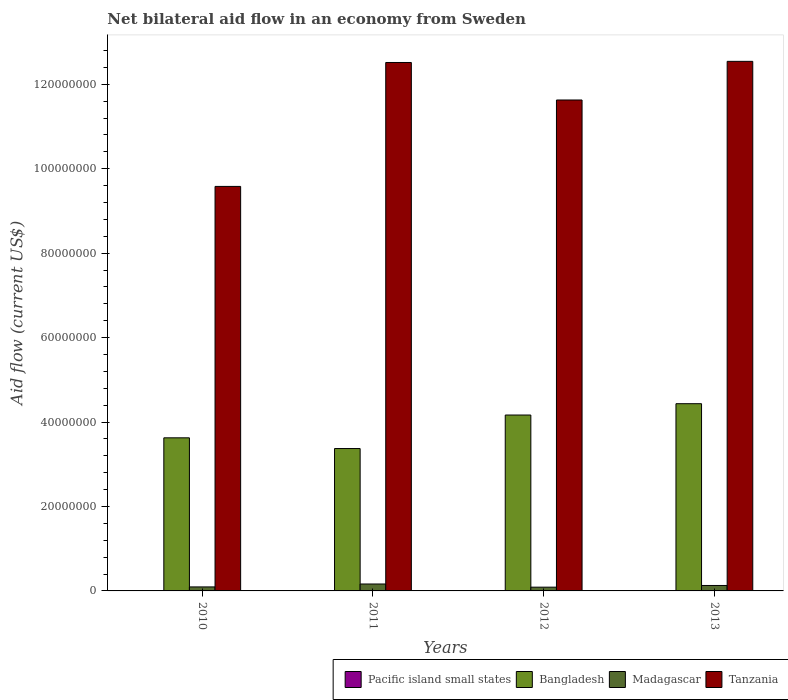How many different coloured bars are there?
Make the answer very short. 4. How many bars are there on the 3rd tick from the left?
Offer a terse response. 3. How many bars are there on the 1st tick from the right?
Offer a very short reply. 4. In how many cases, is the number of bars for a given year not equal to the number of legend labels?
Keep it short and to the point. 1. What is the net bilateral aid flow in Bangladesh in 2011?
Offer a terse response. 3.37e+07. Across all years, what is the maximum net bilateral aid flow in Madagascar?
Offer a terse response. 1.64e+06. Across all years, what is the minimum net bilateral aid flow in Pacific island small states?
Ensure brevity in your answer.  0. What is the total net bilateral aid flow in Pacific island small states in the graph?
Make the answer very short. 1.40e+05. What is the difference between the net bilateral aid flow in Tanzania in 2010 and the net bilateral aid flow in Bangladesh in 2012?
Offer a terse response. 5.41e+07. What is the average net bilateral aid flow in Pacific island small states per year?
Provide a short and direct response. 3.50e+04. In the year 2011, what is the difference between the net bilateral aid flow in Tanzania and net bilateral aid flow in Madagascar?
Provide a short and direct response. 1.24e+08. What is the ratio of the net bilateral aid flow in Tanzania in 2010 to that in 2011?
Your response must be concise. 0.77. Is the difference between the net bilateral aid flow in Tanzania in 2010 and 2013 greater than the difference between the net bilateral aid flow in Madagascar in 2010 and 2013?
Provide a short and direct response. No. In how many years, is the net bilateral aid flow in Madagascar greater than the average net bilateral aid flow in Madagascar taken over all years?
Your answer should be very brief. 2. Is the sum of the net bilateral aid flow in Tanzania in 2012 and 2013 greater than the maximum net bilateral aid flow in Madagascar across all years?
Provide a succinct answer. Yes. How many years are there in the graph?
Make the answer very short. 4. Are the values on the major ticks of Y-axis written in scientific E-notation?
Your answer should be very brief. No. Does the graph contain grids?
Ensure brevity in your answer.  No. Where does the legend appear in the graph?
Your response must be concise. Bottom right. How are the legend labels stacked?
Give a very brief answer. Horizontal. What is the title of the graph?
Offer a very short reply. Net bilateral aid flow in an economy from Sweden. What is the label or title of the X-axis?
Your answer should be very brief. Years. What is the Aid flow (current US$) in Pacific island small states in 2010?
Your answer should be very brief. 2.00e+04. What is the Aid flow (current US$) in Bangladesh in 2010?
Ensure brevity in your answer.  3.63e+07. What is the Aid flow (current US$) in Madagascar in 2010?
Your answer should be very brief. 9.50e+05. What is the Aid flow (current US$) in Tanzania in 2010?
Provide a short and direct response. 9.58e+07. What is the Aid flow (current US$) of Bangladesh in 2011?
Your answer should be very brief. 3.37e+07. What is the Aid flow (current US$) in Madagascar in 2011?
Your answer should be compact. 1.64e+06. What is the Aid flow (current US$) of Tanzania in 2011?
Offer a terse response. 1.25e+08. What is the Aid flow (current US$) in Pacific island small states in 2012?
Make the answer very short. 0. What is the Aid flow (current US$) in Bangladesh in 2012?
Give a very brief answer. 4.17e+07. What is the Aid flow (current US$) in Madagascar in 2012?
Make the answer very short. 8.90e+05. What is the Aid flow (current US$) in Tanzania in 2012?
Make the answer very short. 1.16e+08. What is the Aid flow (current US$) of Bangladesh in 2013?
Offer a terse response. 4.43e+07. What is the Aid flow (current US$) of Madagascar in 2013?
Provide a succinct answer. 1.29e+06. What is the Aid flow (current US$) of Tanzania in 2013?
Ensure brevity in your answer.  1.25e+08. Across all years, what is the maximum Aid flow (current US$) in Bangladesh?
Ensure brevity in your answer.  4.43e+07. Across all years, what is the maximum Aid flow (current US$) in Madagascar?
Offer a very short reply. 1.64e+06. Across all years, what is the maximum Aid flow (current US$) of Tanzania?
Your answer should be compact. 1.25e+08. Across all years, what is the minimum Aid flow (current US$) of Bangladesh?
Your answer should be very brief. 3.37e+07. Across all years, what is the minimum Aid flow (current US$) of Madagascar?
Give a very brief answer. 8.90e+05. Across all years, what is the minimum Aid flow (current US$) of Tanzania?
Offer a very short reply. 9.58e+07. What is the total Aid flow (current US$) in Pacific island small states in the graph?
Offer a very short reply. 1.40e+05. What is the total Aid flow (current US$) of Bangladesh in the graph?
Give a very brief answer. 1.56e+08. What is the total Aid flow (current US$) in Madagascar in the graph?
Offer a very short reply. 4.77e+06. What is the total Aid flow (current US$) in Tanzania in the graph?
Offer a terse response. 4.63e+08. What is the difference between the Aid flow (current US$) in Bangladesh in 2010 and that in 2011?
Offer a very short reply. 2.54e+06. What is the difference between the Aid flow (current US$) in Madagascar in 2010 and that in 2011?
Your response must be concise. -6.90e+05. What is the difference between the Aid flow (current US$) of Tanzania in 2010 and that in 2011?
Provide a short and direct response. -2.94e+07. What is the difference between the Aid flow (current US$) of Bangladesh in 2010 and that in 2012?
Your response must be concise. -5.40e+06. What is the difference between the Aid flow (current US$) of Madagascar in 2010 and that in 2012?
Your response must be concise. 6.00e+04. What is the difference between the Aid flow (current US$) in Tanzania in 2010 and that in 2012?
Give a very brief answer. -2.05e+07. What is the difference between the Aid flow (current US$) in Pacific island small states in 2010 and that in 2013?
Your answer should be compact. -10000. What is the difference between the Aid flow (current US$) in Bangladesh in 2010 and that in 2013?
Make the answer very short. -8.08e+06. What is the difference between the Aid flow (current US$) in Tanzania in 2010 and that in 2013?
Keep it short and to the point. -2.96e+07. What is the difference between the Aid flow (current US$) of Bangladesh in 2011 and that in 2012?
Your answer should be compact. -7.94e+06. What is the difference between the Aid flow (current US$) in Madagascar in 2011 and that in 2012?
Keep it short and to the point. 7.50e+05. What is the difference between the Aid flow (current US$) of Tanzania in 2011 and that in 2012?
Offer a very short reply. 8.88e+06. What is the difference between the Aid flow (current US$) of Pacific island small states in 2011 and that in 2013?
Ensure brevity in your answer.  6.00e+04. What is the difference between the Aid flow (current US$) in Bangladesh in 2011 and that in 2013?
Offer a very short reply. -1.06e+07. What is the difference between the Aid flow (current US$) in Bangladesh in 2012 and that in 2013?
Ensure brevity in your answer.  -2.68e+06. What is the difference between the Aid flow (current US$) of Madagascar in 2012 and that in 2013?
Your answer should be very brief. -4.00e+05. What is the difference between the Aid flow (current US$) of Tanzania in 2012 and that in 2013?
Ensure brevity in your answer.  -9.15e+06. What is the difference between the Aid flow (current US$) in Pacific island small states in 2010 and the Aid flow (current US$) in Bangladesh in 2011?
Give a very brief answer. -3.37e+07. What is the difference between the Aid flow (current US$) in Pacific island small states in 2010 and the Aid flow (current US$) in Madagascar in 2011?
Keep it short and to the point. -1.62e+06. What is the difference between the Aid flow (current US$) of Pacific island small states in 2010 and the Aid flow (current US$) of Tanzania in 2011?
Keep it short and to the point. -1.25e+08. What is the difference between the Aid flow (current US$) in Bangladesh in 2010 and the Aid flow (current US$) in Madagascar in 2011?
Provide a short and direct response. 3.46e+07. What is the difference between the Aid flow (current US$) of Bangladesh in 2010 and the Aid flow (current US$) of Tanzania in 2011?
Your response must be concise. -8.89e+07. What is the difference between the Aid flow (current US$) of Madagascar in 2010 and the Aid flow (current US$) of Tanzania in 2011?
Provide a short and direct response. -1.24e+08. What is the difference between the Aid flow (current US$) in Pacific island small states in 2010 and the Aid flow (current US$) in Bangladesh in 2012?
Offer a very short reply. -4.16e+07. What is the difference between the Aid flow (current US$) of Pacific island small states in 2010 and the Aid flow (current US$) of Madagascar in 2012?
Your response must be concise. -8.70e+05. What is the difference between the Aid flow (current US$) of Pacific island small states in 2010 and the Aid flow (current US$) of Tanzania in 2012?
Provide a succinct answer. -1.16e+08. What is the difference between the Aid flow (current US$) of Bangladesh in 2010 and the Aid flow (current US$) of Madagascar in 2012?
Your answer should be very brief. 3.54e+07. What is the difference between the Aid flow (current US$) of Bangladesh in 2010 and the Aid flow (current US$) of Tanzania in 2012?
Offer a very short reply. -8.00e+07. What is the difference between the Aid flow (current US$) in Madagascar in 2010 and the Aid flow (current US$) in Tanzania in 2012?
Give a very brief answer. -1.15e+08. What is the difference between the Aid flow (current US$) of Pacific island small states in 2010 and the Aid flow (current US$) of Bangladesh in 2013?
Your answer should be compact. -4.43e+07. What is the difference between the Aid flow (current US$) in Pacific island small states in 2010 and the Aid flow (current US$) in Madagascar in 2013?
Provide a short and direct response. -1.27e+06. What is the difference between the Aid flow (current US$) in Pacific island small states in 2010 and the Aid flow (current US$) in Tanzania in 2013?
Provide a short and direct response. -1.25e+08. What is the difference between the Aid flow (current US$) of Bangladesh in 2010 and the Aid flow (current US$) of Madagascar in 2013?
Offer a very short reply. 3.50e+07. What is the difference between the Aid flow (current US$) in Bangladesh in 2010 and the Aid flow (current US$) in Tanzania in 2013?
Your answer should be very brief. -8.92e+07. What is the difference between the Aid flow (current US$) in Madagascar in 2010 and the Aid flow (current US$) in Tanzania in 2013?
Provide a short and direct response. -1.24e+08. What is the difference between the Aid flow (current US$) of Pacific island small states in 2011 and the Aid flow (current US$) of Bangladesh in 2012?
Your answer should be compact. -4.16e+07. What is the difference between the Aid flow (current US$) in Pacific island small states in 2011 and the Aid flow (current US$) in Madagascar in 2012?
Your response must be concise. -8.00e+05. What is the difference between the Aid flow (current US$) of Pacific island small states in 2011 and the Aid flow (current US$) of Tanzania in 2012?
Your response must be concise. -1.16e+08. What is the difference between the Aid flow (current US$) in Bangladesh in 2011 and the Aid flow (current US$) in Madagascar in 2012?
Your response must be concise. 3.28e+07. What is the difference between the Aid flow (current US$) of Bangladesh in 2011 and the Aid flow (current US$) of Tanzania in 2012?
Provide a succinct answer. -8.26e+07. What is the difference between the Aid flow (current US$) of Madagascar in 2011 and the Aid flow (current US$) of Tanzania in 2012?
Your answer should be compact. -1.15e+08. What is the difference between the Aid flow (current US$) of Pacific island small states in 2011 and the Aid flow (current US$) of Bangladesh in 2013?
Offer a terse response. -4.42e+07. What is the difference between the Aid flow (current US$) in Pacific island small states in 2011 and the Aid flow (current US$) in Madagascar in 2013?
Offer a very short reply. -1.20e+06. What is the difference between the Aid flow (current US$) in Pacific island small states in 2011 and the Aid flow (current US$) in Tanzania in 2013?
Provide a short and direct response. -1.25e+08. What is the difference between the Aid flow (current US$) in Bangladesh in 2011 and the Aid flow (current US$) in Madagascar in 2013?
Your answer should be compact. 3.24e+07. What is the difference between the Aid flow (current US$) of Bangladesh in 2011 and the Aid flow (current US$) of Tanzania in 2013?
Provide a short and direct response. -9.17e+07. What is the difference between the Aid flow (current US$) in Madagascar in 2011 and the Aid flow (current US$) in Tanzania in 2013?
Your response must be concise. -1.24e+08. What is the difference between the Aid flow (current US$) in Bangladesh in 2012 and the Aid flow (current US$) in Madagascar in 2013?
Offer a very short reply. 4.04e+07. What is the difference between the Aid flow (current US$) in Bangladesh in 2012 and the Aid flow (current US$) in Tanzania in 2013?
Provide a short and direct response. -8.38e+07. What is the difference between the Aid flow (current US$) in Madagascar in 2012 and the Aid flow (current US$) in Tanzania in 2013?
Make the answer very short. -1.25e+08. What is the average Aid flow (current US$) in Pacific island small states per year?
Give a very brief answer. 3.50e+04. What is the average Aid flow (current US$) of Bangladesh per year?
Give a very brief answer. 3.90e+07. What is the average Aid flow (current US$) in Madagascar per year?
Make the answer very short. 1.19e+06. What is the average Aid flow (current US$) in Tanzania per year?
Offer a very short reply. 1.16e+08. In the year 2010, what is the difference between the Aid flow (current US$) in Pacific island small states and Aid flow (current US$) in Bangladesh?
Keep it short and to the point. -3.62e+07. In the year 2010, what is the difference between the Aid flow (current US$) in Pacific island small states and Aid flow (current US$) in Madagascar?
Provide a succinct answer. -9.30e+05. In the year 2010, what is the difference between the Aid flow (current US$) in Pacific island small states and Aid flow (current US$) in Tanzania?
Provide a succinct answer. -9.58e+07. In the year 2010, what is the difference between the Aid flow (current US$) of Bangladesh and Aid flow (current US$) of Madagascar?
Keep it short and to the point. 3.53e+07. In the year 2010, what is the difference between the Aid flow (current US$) of Bangladesh and Aid flow (current US$) of Tanzania?
Offer a terse response. -5.95e+07. In the year 2010, what is the difference between the Aid flow (current US$) of Madagascar and Aid flow (current US$) of Tanzania?
Provide a succinct answer. -9.48e+07. In the year 2011, what is the difference between the Aid flow (current US$) in Pacific island small states and Aid flow (current US$) in Bangladesh?
Offer a very short reply. -3.36e+07. In the year 2011, what is the difference between the Aid flow (current US$) in Pacific island small states and Aid flow (current US$) in Madagascar?
Keep it short and to the point. -1.55e+06. In the year 2011, what is the difference between the Aid flow (current US$) of Pacific island small states and Aid flow (current US$) of Tanzania?
Make the answer very short. -1.25e+08. In the year 2011, what is the difference between the Aid flow (current US$) in Bangladesh and Aid flow (current US$) in Madagascar?
Offer a very short reply. 3.21e+07. In the year 2011, what is the difference between the Aid flow (current US$) in Bangladesh and Aid flow (current US$) in Tanzania?
Your answer should be compact. -9.14e+07. In the year 2011, what is the difference between the Aid flow (current US$) of Madagascar and Aid flow (current US$) of Tanzania?
Your answer should be compact. -1.24e+08. In the year 2012, what is the difference between the Aid flow (current US$) in Bangladesh and Aid flow (current US$) in Madagascar?
Your response must be concise. 4.08e+07. In the year 2012, what is the difference between the Aid flow (current US$) of Bangladesh and Aid flow (current US$) of Tanzania?
Your answer should be compact. -7.46e+07. In the year 2012, what is the difference between the Aid flow (current US$) in Madagascar and Aid flow (current US$) in Tanzania?
Your response must be concise. -1.15e+08. In the year 2013, what is the difference between the Aid flow (current US$) in Pacific island small states and Aid flow (current US$) in Bangladesh?
Offer a terse response. -4.43e+07. In the year 2013, what is the difference between the Aid flow (current US$) of Pacific island small states and Aid flow (current US$) of Madagascar?
Make the answer very short. -1.26e+06. In the year 2013, what is the difference between the Aid flow (current US$) of Pacific island small states and Aid flow (current US$) of Tanzania?
Provide a short and direct response. -1.25e+08. In the year 2013, what is the difference between the Aid flow (current US$) in Bangladesh and Aid flow (current US$) in Madagascar?
Offer a very short reply. 4.30e+07. In the year 2013, what is the difference between the Aid flow (current US$) in Bangladesh and Aid flow (current US$) in Tanzania?
Provide a succinct answer. -8.11e+07. In the year 2013, what is the difference between the Aid flow (current US$) in Madagascar and Aid flow (current US$) in Tanzania?
Provide a succinct answer. -1.24e+08. What is the ratio of the Aid flow (current US$) in Pacific island small states in 2010 to that in 2011?
Your answer should be very brief. 0.22. What is the ratio of the Aid flow (current US$) of Bangladesh in 2010 to that in 2011?
Make the answer very short. 1.08. What is the ratio of the Aid flow (current US$) of Madagascar in 2010 to that in 2011?
Provide a short and direct response. 0.58. What is the ratio of the Aid flow (current US$) in Tanzania in 2010 to that in 2011?
Make the answer very short. 0.77. What is the ratio of the Aid flow (current US$) of Bangladesh in 2010 to that in 2012?
Your answer should be compact. 0.87. What is the ratio of the Aid flow (current US$) of Madagascar in 2010 to that in 2012?
Offer a terse response. 1.07. What is the ratio of the Aid flow (current US$) in Tanzania in 2010 to that in 2012?
Provide a short and direct response. 0.82. What is the ratio of the Aid flow (current US$) in Pacific island small states in 2010 to that in 2013?
Your answer should be very brief. 0.67. What is the ratio of the Aid flow (current US$) in Bangladesh in 2010 to that in 2013?
Your response must be concise. 0.82. What is the ratio of the Aid flow (current US$) in Madagascar in 2010 to that in 2013?
Your response must be concise. 0.74. What is the ratio of the Aid flow (current US$) in Tanzania in 2010 to that in 2013?
Offer a very short reply. 0.76. What is the ratio of the Aid flow (current US$) of Bangladesh in 2011 to that in 2012?
Give a very brief answer. 0.81. What is the ratio of the Aid flow (current US$) of Madagascar in 2011 to that in 2012?
Provide a short and direct response. 1.84. What is the ratio of the Aid flow (current US$) of Tanzania in 2011 to that in 2012?
Offer a very short reply. 1.08. What is the ratio of the Aid flow (current US$) in Bangladesh in 2011 to that in 2013?
Ensure brevity in your answer.  0.76. What is the ratio of the Aid flow (current US$) in Madagascar in 2011 to that in 2013?
Give a very brief answer. 1.27. What is the ratio of the Aid flow (current US$) in Bangladesh in 2012 to that in 2013?
Keep it short and to the point. 0.94. What is the ratio of the Aid flow (current US$) of Madagascar in 2012 to that in 2013?
Offer a terse response. 0.69. What is the ratio of the Aid flow (current US$) in Tanzania in 2012 to that in 2013?
Offer a very short reply. 0.93. What is the difference between the highest and the second highest Aid flow (current US$) in Bangladesh?
Your response must be concise. 2.68e+06. What is the difference between the highest and the second highest Aid flow (current US$) in Tanzania?
Keep it short and to the point. 2.70e+05. What is the difference between the highest and the lowest Aid flow (current US$) in Pacific island small states?
Ensure brevity in your answer.  9.00e+04. What is the difference between the highest and the lowest Aid flow (current US$) in Bangladesh?
Your answer should be compact. 1.06e+07. What is the difference between the highest and the lowest Aid flow (current US$) in Madagascar?
Give a very brief answer. 7.50e+05. What is the difference between the highest and the lowest Aid flow (current US$) of Tanzania?
Provide a short and direct response. 2.96e+07. 